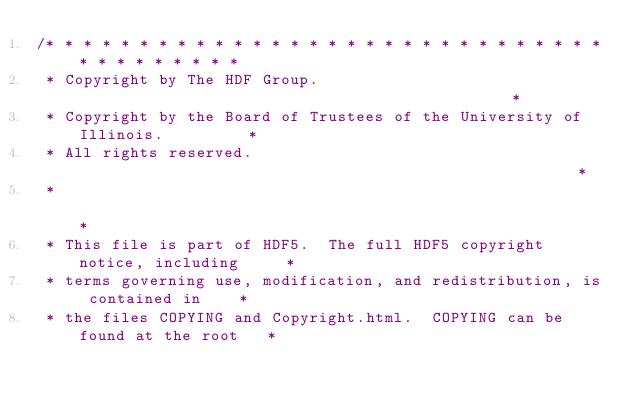<code> <loc_0><loc_0><loc_500><loc_500><_C_>/* * * * * * * * * * * * * * * * * * * * * * * * * * * * * * * * * * * * * * *
 * Copyright by The HDF Group.                                               *
 * Copyright by the Board of Trustees of the University of Illinois.         *
 * All rights reserved.                                                      *
 *                                                                           *
 * This file is part of HDF5.  The full HDF5 copyright notice, including     *
 * terms governing use, modification, and redistribution, is contained in    *
 * the files COPYING and Copyright.html.  COPYING can be found at the root   *</code> 